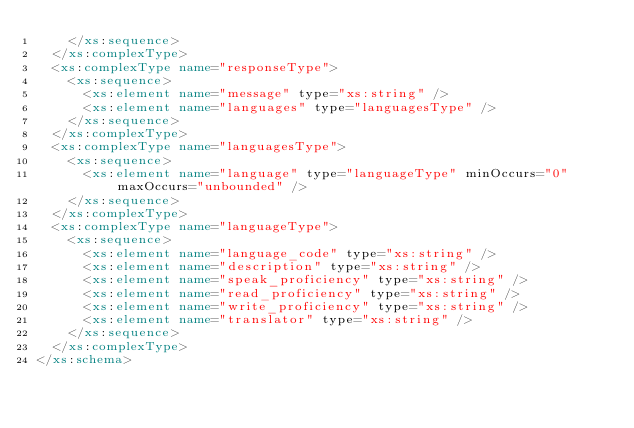Convert code to text. <code><loc_0><loc_0><loc_500><loc_500><_XML_>		</xs:sequence>
	</xs:complexType>
	<xs:complexType name="responseType">
		<xs:sequence>
			<xs:element name="message" type="xs:string" />
			<xs:element name="languages" type="languagesType" />
		</xs:sequence>
	</xs:complexType>
	<xs:complexType name="languagesType">
		<xs:sequence>
			<xs:element name="language" type="languageType" minOccurs="0" maxOccurs="unbounded" />
		</xs:sequence>
	</xs:complexType>
	<xs:complexType name="languageType">
		<xs:sequence>
			<xs:element name="language_code" type="xs:string" />
			<xs:element name="description" type="xs:string" />
			<xs:element name="speak_proficiency" type="xs:string" />
			<xs:element name="read_proficiency" type="xs:string" />
			<xs:element name="write_proficiency" type="xs:string" />
			<xs:element name="translator" type="xs:string" />
		</xs:sequence>
	</xs:complexType>
</xs:schema>
</code> 